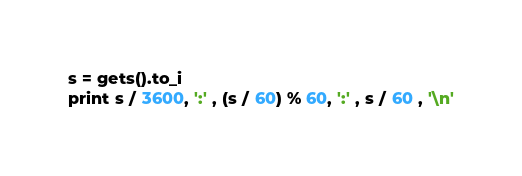<code> <loc_0><loc_0><loc_500><loc_500><_Ruby_>s = gets().to_i
print s / 3600, ':' , (s / 60) % 60, ':' , s / 60 , '\n'
</code> 